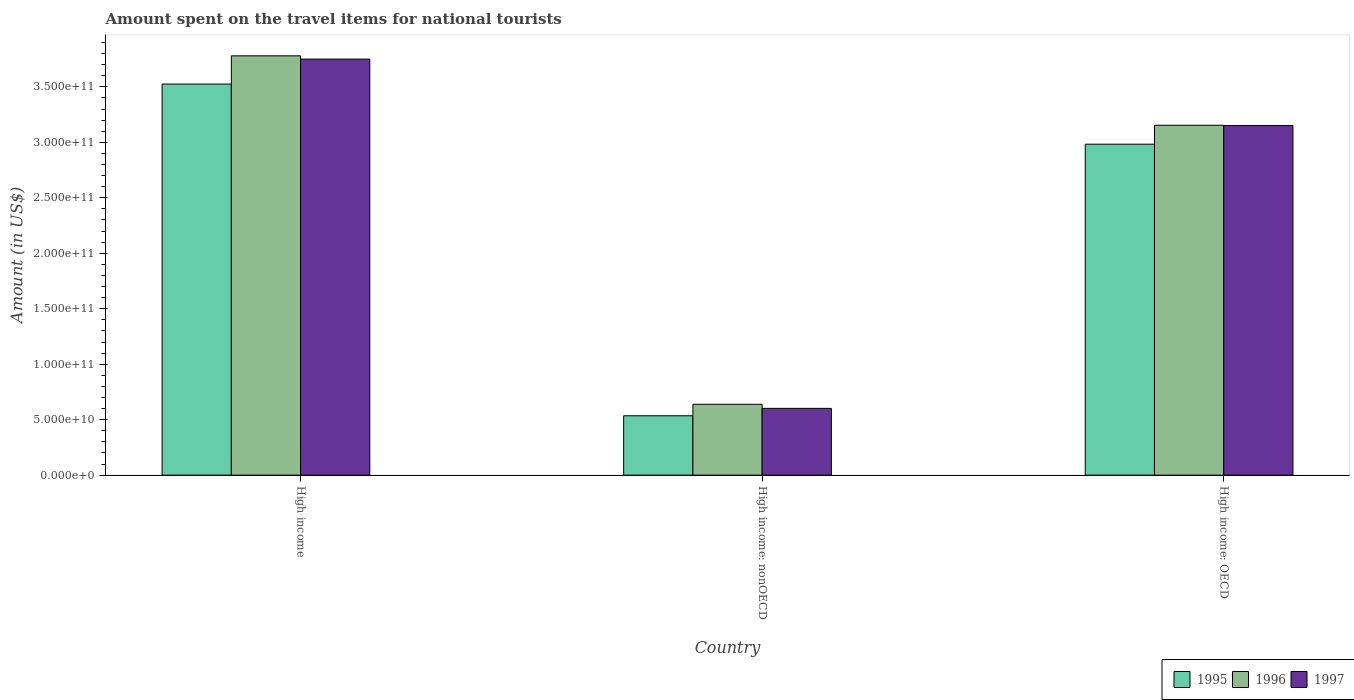Are the number of bars per tick equal to the number of legend labels?
Offer a very short reply. Yes. Are the number of bars on each tick of the X-axis equal?
Offer a very short reply. Yes. How many bars are there on the 2nd tick from the right?
Your answer should be very brief. 3. What is the label of the 3rd group of bars from the left?
Your answer should be very brief. High income: OECD. What is the amount spent on the travel items for national tourists in 1996 in High income: nonOECD?
Ensure brevity in your answer.  6.39e+1. Across all countries, what is the maximum amount spent on the travel items for national tourists in 1995?
Keep it short and to the point. 3.52e+11. Across all countries, what is the minimum amount spent on the travel items for national tourists in 1996?
Give a very brief answer. 6.39e+1. In which country was the amount spent on the travel items for national tourists in 1996 minimum?
Ensure brevity in your answer.  High income: nonOECD. What is the total amount spent on the travel items for national tourists in 1995 in the graph?
Keep it short and to the point. 7.04e+11. What is the difference between the amount spent on the travel items for national tourists in 1997 in High income: OECD and that in High income: nonOECD?
Ensure brevity in your answer.  2.55e+11. What is the difference between the amount spent on the travel items for national tourists in 1996 in High income: nonOECD and the amount spent on the travel items for national tourists in 1997 in High income?
Offer a terse response. -3.11e+11. What is the average amount spent on the travel items for national tourists in 1996 per country?
Keep it short and to the point. 2.52e+11. What is the difference between the amount spent on the travel items for national tourists of/in 1996 and amount spent on the travel items for national tourists of/in 1997 in High income?
Make the answer very short. 2.94e+09. What is the ratio of the amount spent on the travel items for national tourists in 1997 in High income to that in High income: OECD?
Keep it short and to the point. 1.19. Is the amount spent on the travel items for national tourists in 1996 in High income less than that in High income: OECD?
Offer a very short reply. No. Is the difference between the amount spent on the travel items for national tourists in 1996 in High income and High income: OECD greater than the difference between the amount spent on the travel items for national tourists in 1997 in High income and High income: OECD?
Your answer should be compact. Yes. What is the difference between the highest and the second highest amount spent on the travel items for national tourists in 1997?
Keep it short and to the point. -5.99e+1. What is the difference between the highest and the lowest amount spent on the travel items for national tourists in 1995?
Provide a succinct answer. 2.99e+11. In how many countries, is the amount spent on the travel items for national tourists in 1997 greater than the average amount spent on the travel items for national tourists in 1997 taken over all countries?
Give a very brief answer. 2. Is it the case that in every country, the sum of the amount spent on the travel items for national tourists in 1996 and amount spent on the travel items for national tourists in 1997 is greater than the amount spent on the travel items for national tourists in 1995?
Offer a terse response. Yes. How many bars are there?
Make the answer very short. 9. Does the graph contain any zero values?
Make the answer very short. No. What is the title of the graph?
Make the answer very short. Amount spent on the travel items for national tourists. Does "1987" appear as one of the legend labels in the graph?
Offer a terse response. No. What is the label or title of the X-axis?
Provide a succinct answer. Country. What is the label or title of the Y-axis?
Keep it short and to the point. Amount (in US$). What is the Amount (in US$) of 1995 in High income?
Your answer should be compact. 3.52e+11. What is the Amount (in US$) in 1996 in High income?
Your response must be concise. 3.78e+11. What is the Amount (in US$) of 1997 in High income?
Ensure brevity in your answer.  3.75e+11. What is the Amount (in US$) of 1995 in High income: nonOECD?
Provide a short and direct response. 5.35e+1. What is the Amount (in US$) in 1996 in High income: nonOECD?
Give a very brief answer. 6.39e+1. What is the Amount (in US$) in 1997 in High income: nonOECD?
Provide a succinct answer. 6.02e+1. What is the Amount (in US$) in 1995 in High income: OECD?
Provide a succinct answer. 2.98e+11. What is the Amount (in US$) of 1996 in High income: OECD?
Make the answer very short. 3.15e+11. What is the Amount (in US$) in 1997 in High income: OECD?
Ensure brevity in your answer.  3.15e+11. Across all countries, what is the maximum Amount (in US$) in 1995?
Make the answer very short. 3.52e+11. Across all countries, what is the maximum Amount (in US$) of 1996?
Offer a very short reply. 3.78e+11. Across all countries, what is the maximum Amount (in US$) in 1997?
Your answer should be compact. 3.75e+11. Across all countries, what is the minimum Amount (in US$) in 1995?
Provide a short and direct response. 5.35e+1. Across all countries, what is the minimum Amount (in US$) of 1996?
Your answer should be very brief. 6.39e+1. Across all countries, what is the minimum Amount (in US$) of 1997?
Your response must be concise. 6.02e+1. What is the total Amount (in US$) of 1995 in the graph?
Provide a succinct answer. 7.04e+11. What is the total Amount (in US$) of 1996 in the graph?
Offer a terse response. 7.57e+11. What is the total Amount (in US$) in 1997 in the graph?
Make the answer very short. 7.50e+11. What is the difference between the Amount (in US$) in 1995 in High income and that in High income: nonOECD?
Your answer should be compact. 2.99e+11. What is the difference between the Amount (in US$) in 1996 in High income and that in High income: nonOECD?
Make the answer very short. 3.14e+11. What is the difference between the Amount (in US$) of 1997 in High income and that in High income: nonOECD?
Provide a short and direct response. 3.15e+11. What is the difference between the Amount (in US$) in 1995 in High income and that in High income: OECD?
Keep it short and to the point. 5.42e+1. What is the difference between the Amount (in US$) of 1996 in High income and that in High income: OECD?
Ensure brevity in your answer.  6.26e+1. What is the difference between the Amount (in US$) in 1997 in High income and that in High income: OECD?
Give a very brief answer. 5.99e+1. What is the difference between the Amount (in US$) of 1995 in High income: nonOECD and that in High income: OECD?
Make the answer very short. -2.45e+11. What is the difference between the Amount (in US$) of 1996 in High income: nonOECD and that in High income: OECD?
Offer a terse response. -2.51e+11. What is the difference between the Amount (in US$) of 1997 in High income: nonOECD and that in High income: OECD?
Keep it short and to the point. -2.55e+11. What is the difference between the Amount (in US$) in 1995 in High income and the Amount (in US$) in 1996 in High income: nonOECD?
Your answer should be compact. 2.89e+11. What is the difference between the Amount (in US$) of 1995 in High income and the Amount (in US$) of 1997 in High income: nonOECD?
Your response must be concise. 2.92e+11. What is the difference between the Amount (in US$) in 1996 in High income and the Amount (in US$) in 1997 in High income: nonOECD?
Provide a succinct answer. 3.18e+11. What is the difference between the Amount (in US$) in 1995 in High income and the Amount (in US$) in 1996 in High income: OECD?
Provide a succinct answer. 3.71e+1. What is the difference between the Amount (in US$) in 1995 in High income and the Amount (in US$) in 1997 in High income: OECD?
Your answer should be very brief. 3.74e+1. What is the difference between the Amount (in US$) of 1996 in High income and the Amount (in US$) of 1997 in High income: OECD?
Give a very brief answer. 6.28e+1. What is the difference between the Amount (in US$) of 1995 in High income: nonOECD and the Amount (in US$) of 1996 in High income: OECD?
Make the answer very short. -2.62e+11. What is the difference between the Amount (in US$) in 1995 in High income: nonOECD and the Amount (in US$) in 1997 in High income: OECD?
Your answer should be compact. -2.62e+11. What is the difference between the Amount (in US$) of 1996 in High income: nonOECD and the Amount (in US$) of 1997 in High income: OECD?
Make the answer very short. -2.51e+11. What is the average Amount (in US$) of 1995 per country?
Your response must be concise. 2.35e+11. What is the average Amount (in US$) in 1996 per country?
Give a very brief answer. 2.52e+11. What is the average Amount (in US$) of 1997 per country?
Your answer should be compact. 2.50e+11. What is the difference between the Amount (in US$) of 1995 and Amount (in US$) of 1996 in High income?
Offer a very short reply. -2.54e+1. What is the difference between the Amount (in US$) of 1995 and Amount (in US$) of 1997 in High income?
Make the answer very short. -2.25e+1. What is the difference between the Amount (in US$) in 1996 and Amount (in US$) in 1997 in High income?
Make the answer very short. 2.94e+09. What is the difference between the Amount (in US$) of 1995 and Amount (in US$) of 1996 in High income: nonOECD?
Your answer should be very brief. -1.04e+1. What is the difference between the Amount (in US$) of 1995 and Amount (in US$) of 1997 in High income: nonOECD?
Give a very brief answer. -6.67e+09. What is the difference between the Amount (in US$) of 1996 and Amount (in US$) of 1997 in High income: nonOECD?
Offer a terse response. 3.69e+09. What is the difference between the Amount (in US$) of 1995 and Amount (in US$) of 1996 in High income: OECD?
Your response must be concise. -1.71e+1. What is the difference between the Amount (in US$) of 1995 and Amount (in US$) of 1997 in High income: OECD?
Keep it short and to the point. -1.68e+1. What is the difference between the Amount (in US$) of 1996 and Amount (in US$) of 1997 in High income: OECD?
Give a very brief answer. 2.50e+08. What is the ratio of the Amount (in US$) of 1995 in High income to that in High income: nonOECD?
Provide a succinct answer. 6.58. What is the ratio of the Amount (in US$) in 1996 in High income to that in High income: nonOECD?
Keep it short and to the point. 5.91. What is the ratio of the Amount (in US$) in 1997 in High income to that in High income: nonOECD?
Provide a short and direct response. 6.23. What is the ratio of the Amount (in US$) of 1995 in High income to that in High income: OECD?
Ensure brevity in your answer.  1.18. What is the ratio of the Amount (in US$) in 1996 in High income to that in High income: OECD?
Offer a very short reply. 1.2. What is the ratio of the Amount (in US$) in 1997 in High income to that in High income: OECD?
Give a very brief answer. 1.19. What is the ratio of the Amount (in US$) in 1995 in High income: nonOECD to that in High income: OECD?
Offer a terse response. 0.18. What is the ratio of the Amount (in US$) of 1996 in High income: nonOECD to that in High income: OECD?
Provide a succinct answer. 0.2. What is the ratio of the Amount (in US$) of 1997 in High income: nonOECD to that in High income: OECD?
Provide a short and direct response. 0.19. What is the difference between the highest and the second highest Amount (in US$) in 1995?
Your answer should be very brief. 5.42e+1. What is the difference between the highest and the second highest Amount (in US$) in 1996?
Ensure brevity in your answer.  6.26e+1. What is the difference between the highest and the second highest Amount (in US$) in 1997?
Your answer should be compact. 5.99e+1. What is the difference between the highest and the lowest Amount (in US$) of 1995?
Provide a succinct answer. 2.99e+11. What is the difference between the highest and the lowest Amount (in US$) in 1996?
Keep it short and to the point. 3.14e+11. What is the difference between the highest and the lowest Amount (in US$) in 1997?
Keep it short and to the point. 3.15e+11. 